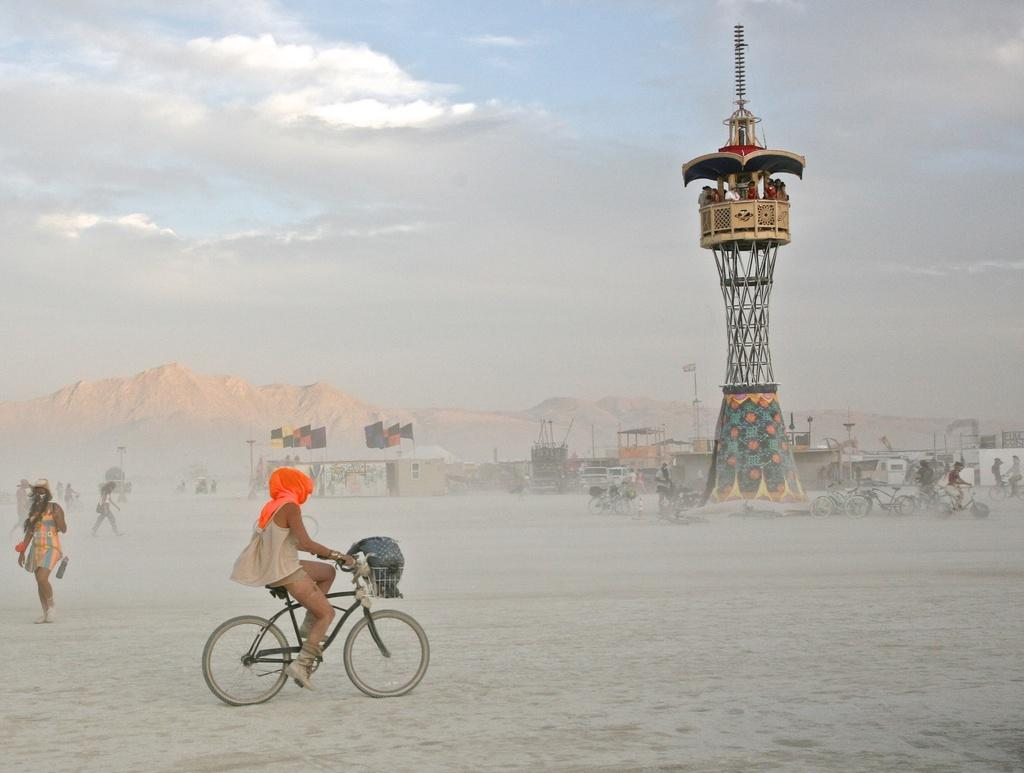What are the people in the image doing? Some people are riding bicycles, and some people are walking. What might be the reason for the people's activities in the image? The area in the image appears to be covered in snow, which could explain why some people are riding bicycles and others are walking. Can you see any oranges in the image? There are no oranges present in the image. Is there an airport visible in the image? There is no airport visible in the image. 